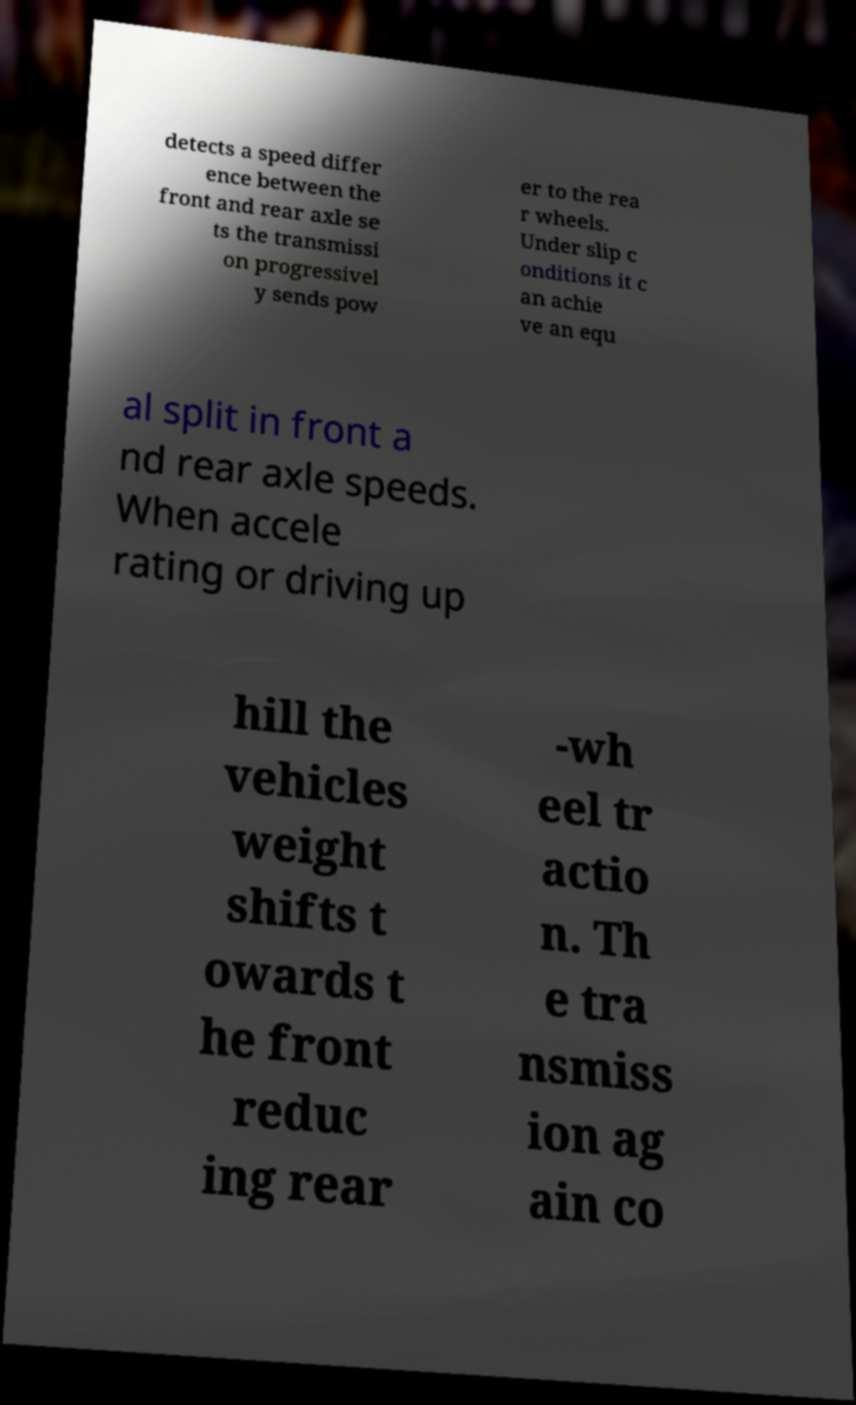Can you accurately transcribe the text from the provided image for me? detects a speed differ ence between the front and rear axle se ts the transmissi on progressivel y sends pow er to the rea r wheels. Under slip c onditions it c an achie ve an equ al split in front a nd rear axle speeds. When accele rating or driving up hill the vehicles weight shifts t owards t he front reduc ing rear -wh eel tr actio n. Th e tra nsmiss ion ag ain co 